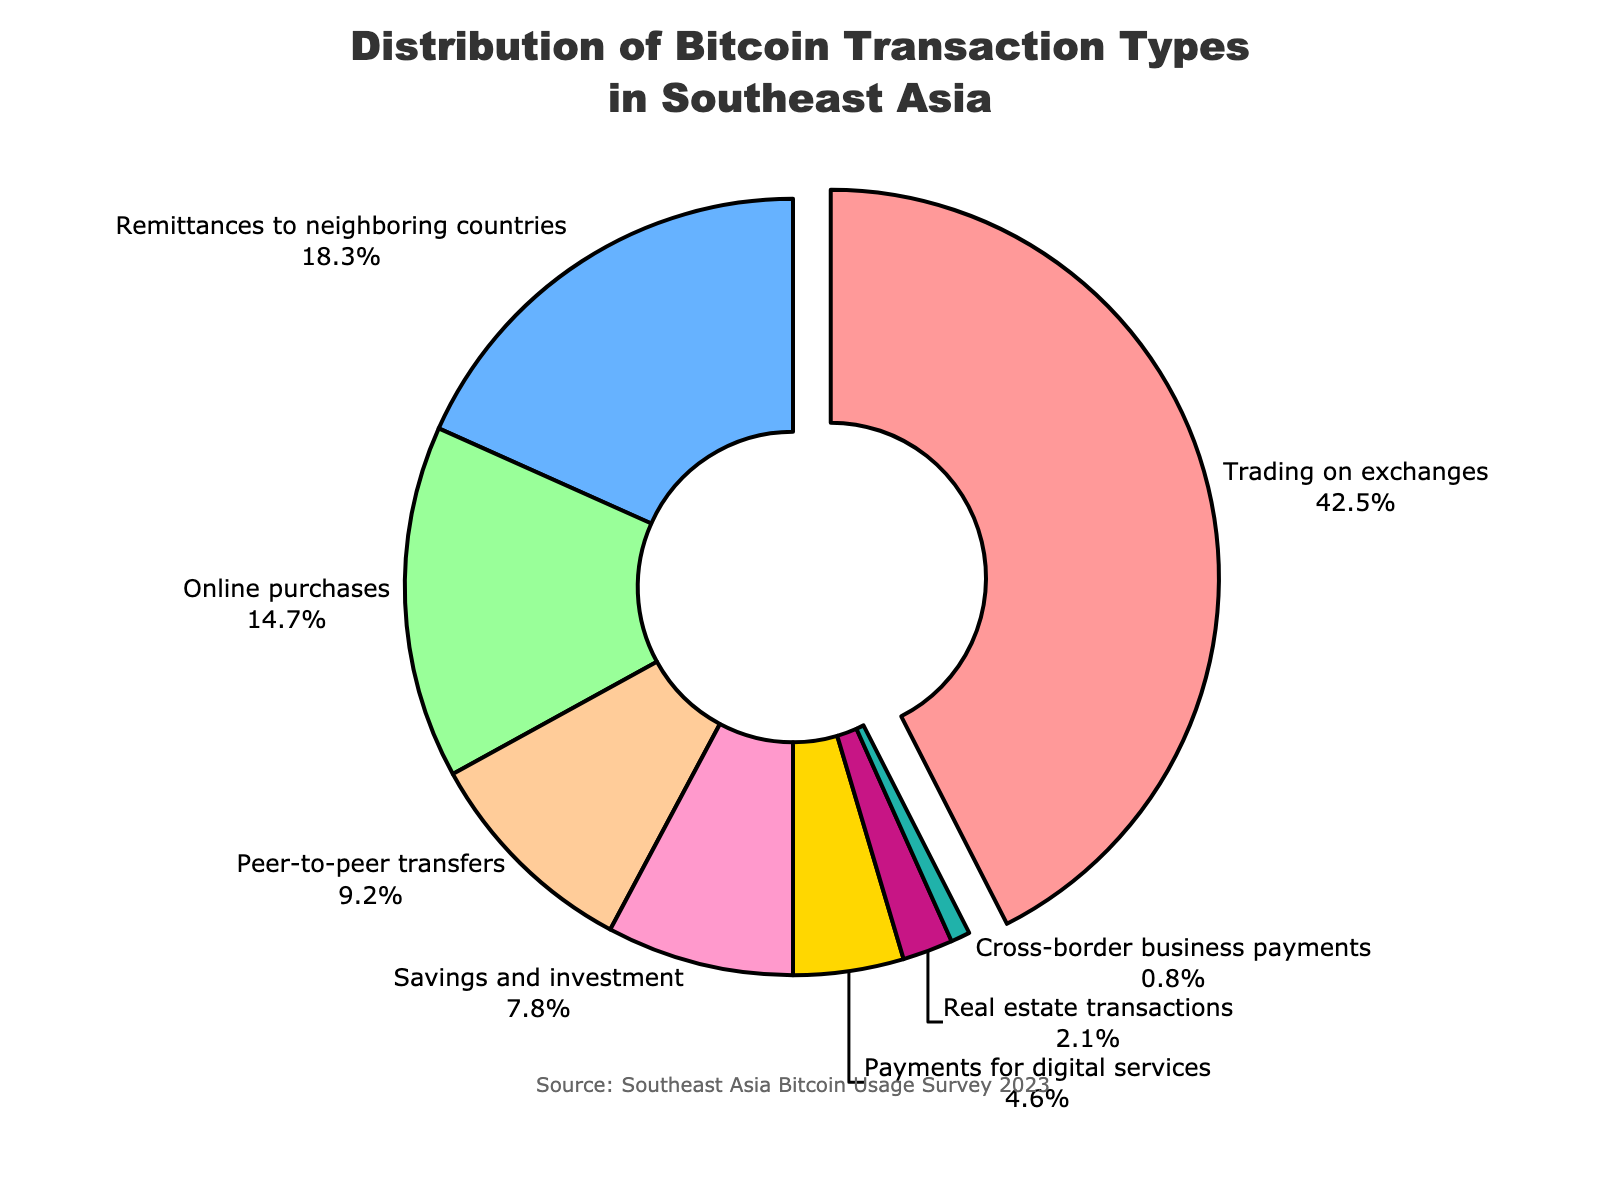What is the largest category of Bitcoin transactions in Southeast Asia? The figure shows a pie chart with different categories of Bitcoin transactions and their respective percentages. The largest slice represents the largest category. According to the chart, "Trading on exchanges" has the largest percentage at 42.5%.
Answer: Trading on exchanges What percentage of Bitcoin transactions is used for savings and investment in Southeast Asia? The figure has individual percentage values for each transaction type along with their labels. The slice labeled "Savings and investment" shows a percentage value, which is 7.8%.
Answer: 7.8% How much more common are trading transactions compared to online purchases in Southeast Asia? From the chart, we see that "Trading on exchanges" is 42.5% and "Online purchases" is 14.7%. By subtracting these values, the difference is 42.5% - 14.7% = 27.8%.
Answer: 27.8% Which categories together make up the majority (>50%) of Bitcoin transactions? The chart provides percentages for each category. Adding the largest percentages until the sum exceeds 50%: "Trading on exchanges" (42.5%) and "Remittances to neighboring countries" (18.3%) together sum to 60.8%, which is more than 50%.
Answer: Trading on exchanges and Remittances to neighboring countries What is the sum percentage of peer-to-peer transfers and payments for digital services? We can simply add the percentages for both categories. "Peer-to-peer transfers" is 9.2% and "Payments for digital services" is 4.6%. Adding these together gives 9.2% + 4.6% = 13.8%.
Answer: 13.8% Is cross-border business payments more or less common than real estate transactions? By examining the percentages provided in the chart, cross-border business payments have a percentage of 0.8%, while real estate transactions are at 2.1%. Cross-border business payments (0.8%) are less common than real estate transactions (2.1%).
Answer: Less What percentage of transactions are used for purposes other than trading on exchanges and remittances to neighboring countries? First, find the sum of the percentages for "Trading on exchanges" and "Remittances to neighboring countries," which is 42.5% + 18.3% = 60.8%. Then, subtract this from 100% to find the percentage for other purposes: 100% - 60.8% = 39.2%.
Answer: 39.2% What color is the slice representing online purchases in the pie chart? The customized colors in the pie chart have been assigned in a visible and distinguishable manner. According to the ordering in the pie chart, the slice for "Online purchases" is colored in green.
Answer: Green 